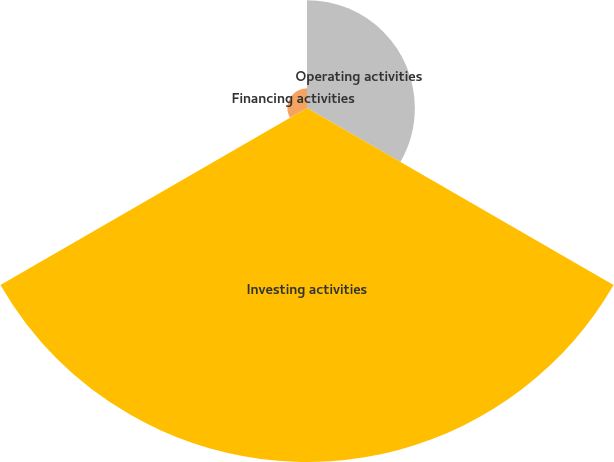<chart> <loc_0><loc_0><loc_500><loc_500><pie_chart><fcel>Operating activities<fcel>Investing activities<fcel>Financing activities<nl><fcel>22.4%<fcel>73.52%<fcel>4.08%<nl></chart> 